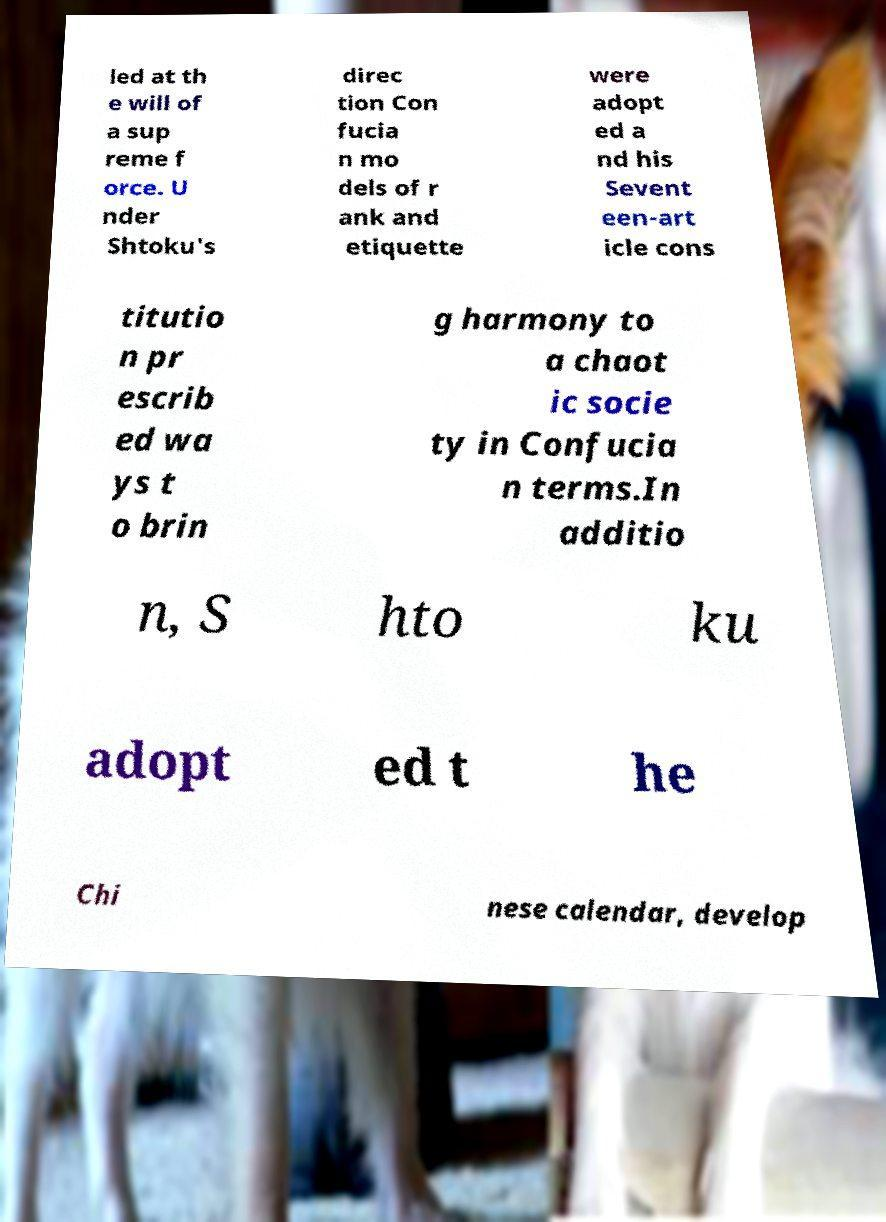What messages or text are displayed in this image? I need them in a readable, typed format. led at th e will of a sup reme f orce. U nder Shtoku's direc tion Con fucia n mo dels of r ank and etiquette were adopt ed a nd his Sevent een-art icle cons titutio n pr escrib ed wa ys t o brin g harmony to a chaot ic socie ty in Confucia n terms.In additio n, S hto ku adopt ed t he Chi nese calendar, develop 